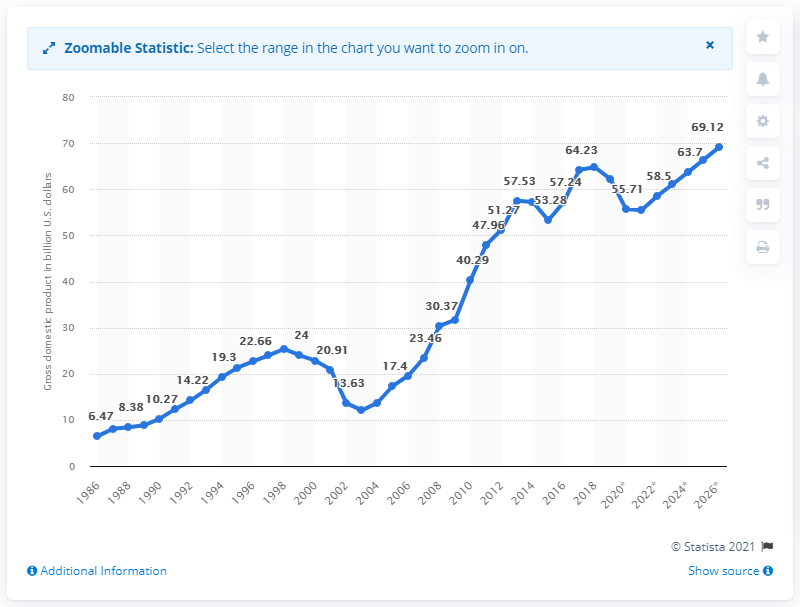List a handful of essential elements in this visual. In 2019, the Gross Domestic Product (GDP) of Uruguay was 62.21. 